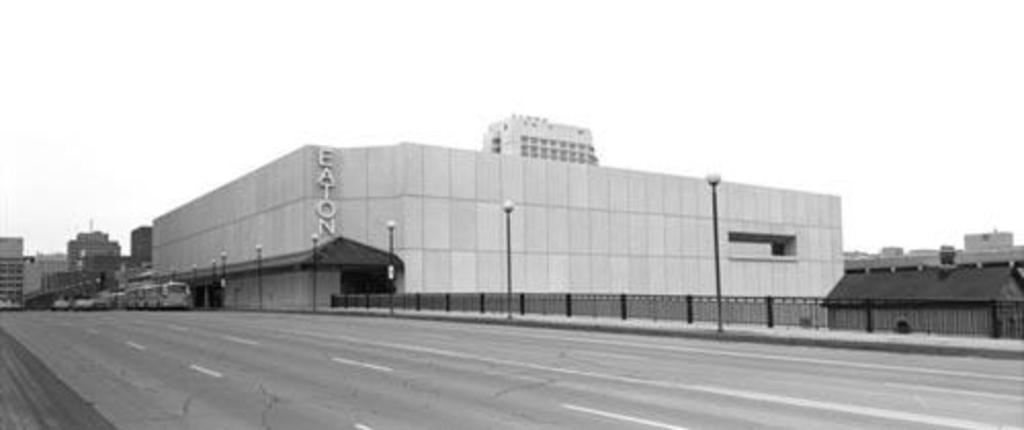In one or two sentences, can you explain what this image depicts? In this picture we can see few vehicles on the road, beside to the vehicles we can find fence, poles, lights and buildings. 